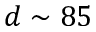Convert formula to latex. <formula><loc_0><loc_0><loc_500><loc_500>d \sim 8 5</formula> 